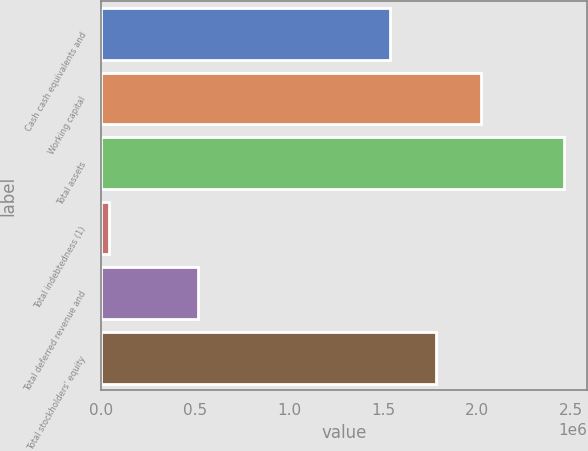Convert chart. <chart><loc_0><loc_0><loc_500><loc_500><bar_chart><fcel>Cash cash equivalents and<fcel>Working capital<fcel>Total assets<fcel>Total indebtedness (1)<fcel>Total deferred revenue and<fcel>Total stockholders' equity<nl><fcel>1.53556e+06<fcel>2.01981e+06<fcel>2.46086e+06<fcel>39592<fcel>515262<fcel>1.77768e+06<nl></chart> 